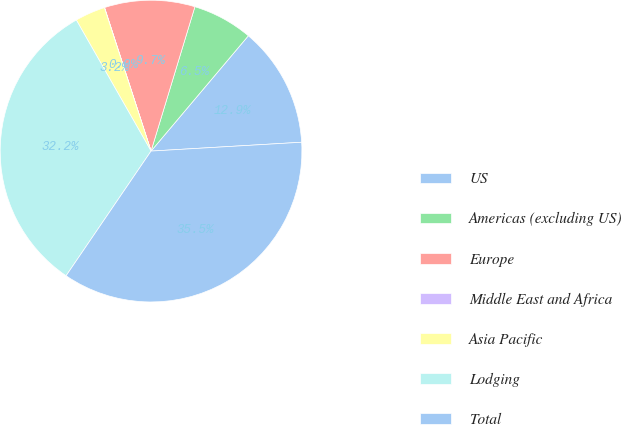<chart> <loc_0><loc_0><loc_500><loc_500><pie_chart><fcel>US<fcel>Americas (excluding US)<fcel>Europe<fcel>Middle East and Africa<fcel>Asia Pacific<fcel>Lodging<fcel>Total<nl><fcel>12.91%<fcel>6.46%<fcel>9.68%<fcel>0.02%<fcel>3.24%<fcel>32.23%<fcel>35.45%<nl></chart> 